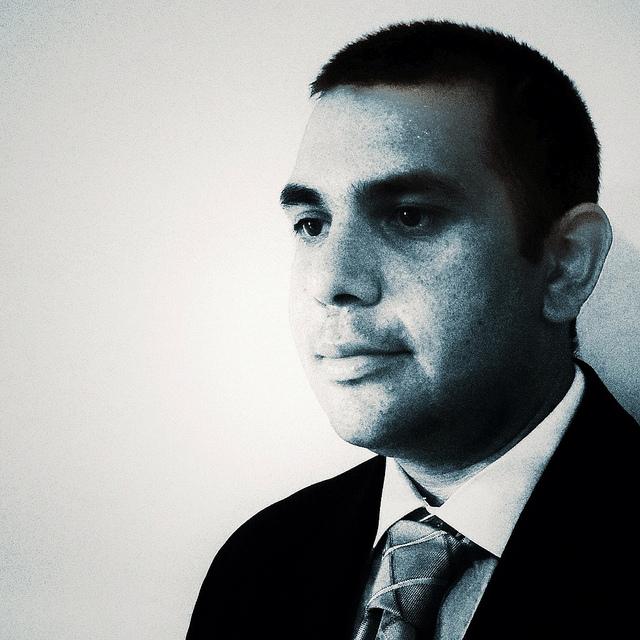Does the man look excited?
Quick response, please. No. Male or female?
Write a very short answer. Male. Does he have any facial hair?
Write a very short answer. No. Is this man dressed casual?
Give a very brief answer. No. 